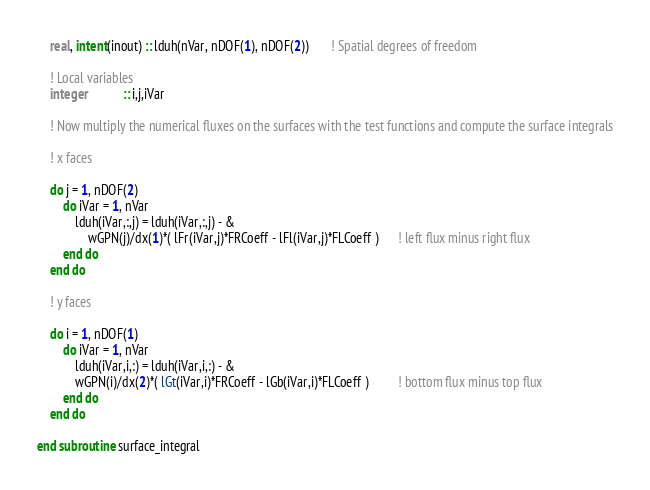<code> <loc_0><loc_0><loc_500><loc_500><_FORTRAN_>    real, intent(inout) :: lduh(nVar, nDOF(1), nDOF(2))       ! Spatial degrees of freedom

    ! Local variables
    integer           :: i,j,iVar

    ! Now multiply the numerical fluxes on the surfaces with the test functions and compute the surface integrals

    ! x faces

    do j = 1, nDOF(2)
        do iVar = 1, nVar
            lduh(iVar,:,j) = lduh(iVar,:,j) - &
                wGPN(j)/dx(1)*( lFr(iVar,j)*FRCoeff - lFl(iVar,j)*FLCoeff )      ! left flux minus right flux
        end do
    end do

    ! y faces

    do i = 1, nDOF(1)
        do iVar = 1, nVar
            lduh(iVar,i,:) = lduh(iVar,i,:) - &
            wGPN(i)/dx(2)*( lGt(iVar,i)*FRCoeff - lGb(iVar,i)*FLCoeff )         ! bottom flux minus top flux
        end do
    end do

end subroutine surface_integral
</code> 